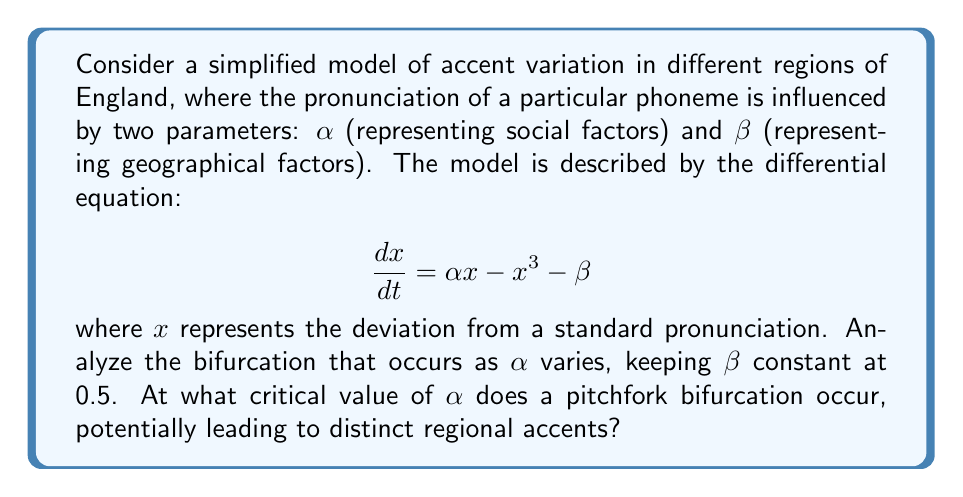Can you solve this math problem? To analyze the bifurcation, we follow these steps:

1) First, find the equilibrium points by setting $\frac{dx}{dt} = 0$:

   $$\alpha x - x^3 - \beta = 0$$

2) Rearrange the equation:

   $$x^3 - \alpha x + \beta = 0$$

3) For a pitchfork bifurcation, we need three roots to coincide. This occurs when both the function and its derivative are zero at the same point. Let's call this point $x_c$.

4) The derivative of $x^3 - \alpha x + \beta$ with respect to $x$ is:

   $$3x^2 - \alpha = 0$$

5) Solving for $x_c$:

   $$x_c = \pm\sqrt{\frac{\alpha}{3}}$$

6) For the pitchfork bifurcation, we need these roots to also satisfy the original equation:

   $$(\pm\sqrt{\frac{\alpha}{3}})^3 - \alpha(\pm\sqrt{\frac{\alpha}{3}}) + \beta = 0$$

7) Simplify:

   $$\pm\frac{\alpha\sqrt{\alpha}}{3\sqrt{3}} - \alpha(\pm\sqrt{\frac{\alpha}{3}}) + \beta = 0$$

8) The $\pm$ terms cancel out:

   $$\frac{\alpha\sqrt{\alpha}}{3\sqrt{3}} - \alpha\sqrt{\frac{\alpha}{3}} + \beta = 0$$

9) Substitute $\beta = 0.5$ and simplify:

   $$\frac{\alpha\sqrt{\alpha}}{3\sqrt{3}} - \sqrt{\frac{\alpha^3}{3}} + 0.5 = 0$$

10) This equation is satisfied when $\alpha = \frac{3}{2}$

Therefore, the pitchfork bifurcation occurs at the critical value $\alpha = \frac{3}{2}$.
Answer: $\frac{3}{2}$ 